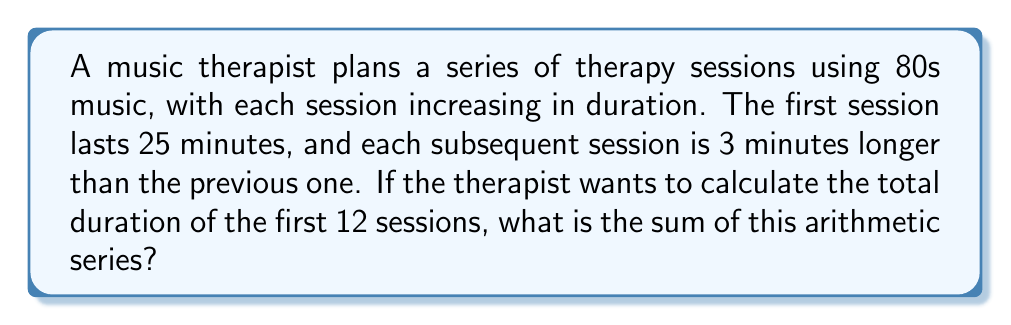Teach me how to tackle this problem. To solve this problem, we'll use the formula for the sum of an arithmetic series:

$$S_n = \frac{n}{2}(a_1 + a_n)$$

Where:
$S_n$ is the sum of the series
$n$ is the number of terms
$a_1$ is the first term
$a_n$ is the last term

Given:
- First session (a_1) = 25 minutes
- Common difference (d) = 3 minutes
- Number of sessions (n) = 12

Step 1: Find the last term (a_n)
$$a_n = a_1 + (n-1)d$$
$$a_{12} = 25 + (12-1)(3) = 25 + 33 = 58$$

Step 2: Apply the formula for the sum of an arithmetic series
$$S_{12} = \frac{12}{2}(25 + 58)$$
$$S_{12} = 6(83)$$
$$S_{12} = 498$$

Therefore, the total duration of the first 12 sessions is 498 minutes.
Answer: 498 minutes 